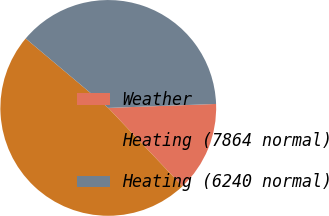Convert chart. <chart><loc_0><loc_0><loc_500><loc_500><pie_chart><fcel>Weather<fcel>Heating (7864 normal)<fcel>Heating (6240 normal)<nl><fcel>13.52%<fcel>48.19%<fcel>38.29%<nl></chart> 